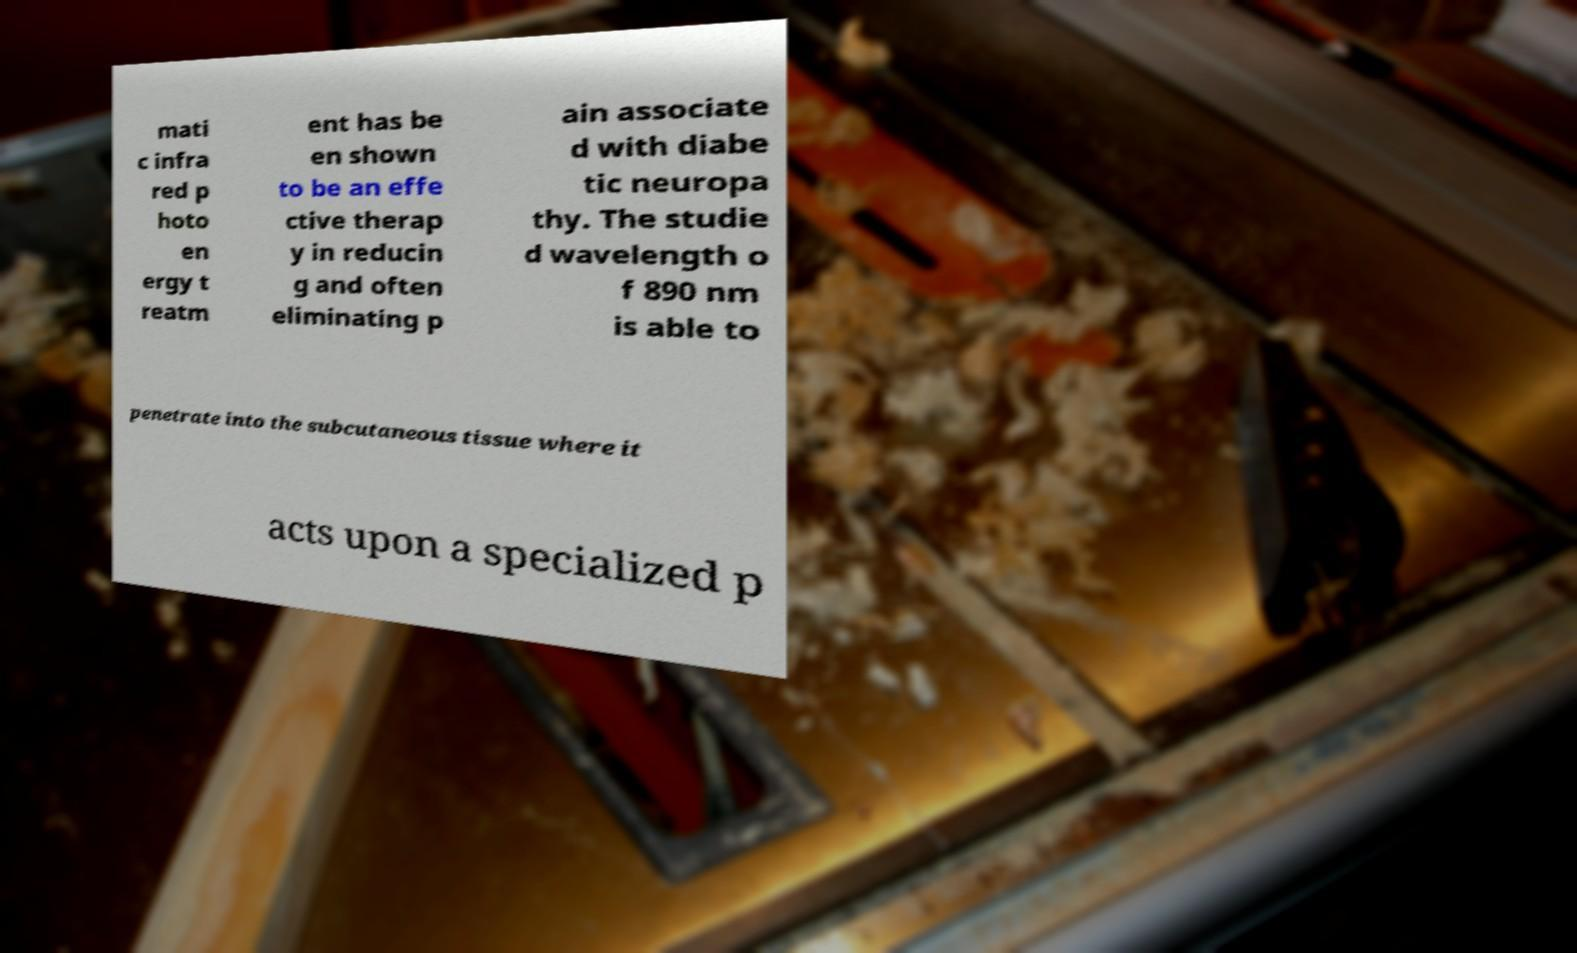What messages or text are displayed in this image? I need them in a readable, typed format. mati c infra red p hoto en ergy t reatm ent has be en shown to be an effe ctive therap y in reducin g and often eliminating p ain associate d with diabe tic neuropa thy. The studie d wavelength o f 890 nm is able to penetrate into the subcutaneous tissue where it acts upon a specialized p 